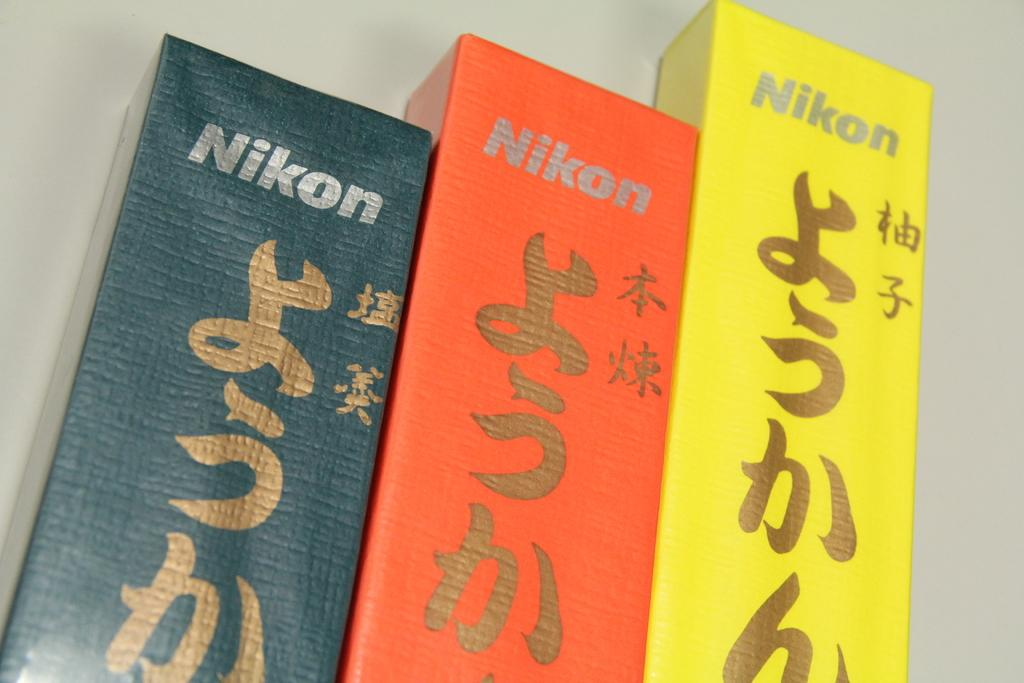<image>
Relay a brief, clear account of the picture shown. Three Nikon boxes are lined up in a staggered row. 